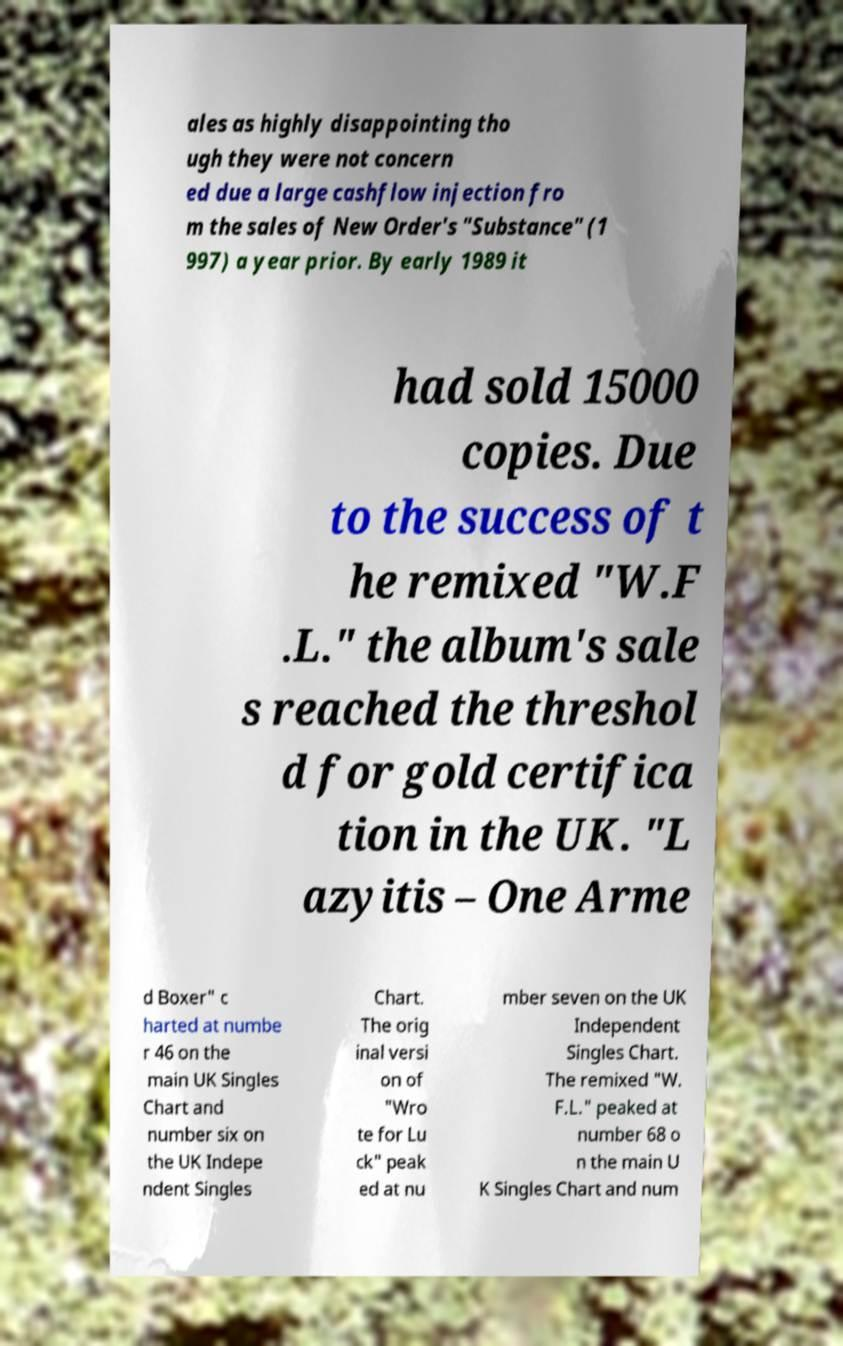There's text embedded in this image that I need extracted. Can you transcribe it verbatim? ales as highly disappointing tho ugh they were not concern ed due a large cashflow injection fro m the sales of New Order's "Substance" (1 997) a year prior. By early 1989 it had sold 15000 copies. Due to the success of t he remixed "W.F .L." the album's sale s reached the threshol d for gold certifica tion in the UK. "L azyitis – One Arme d Boxer" c harted at numbe r 46 on the main UK Singles Chart and number six on the UK Indepe ndent Singles Chart. The orig inal versi on of "Wro te for Lu ck" peak ed at nu mber seven on the UK Independent Singles Chart. The remixed "W. F.L." peaked at number 68 o n the main U K Singles Chart and num 